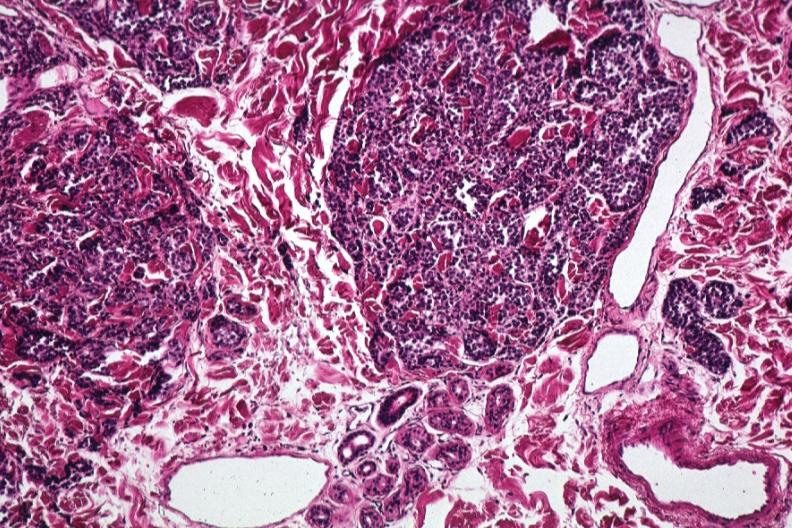what is present?
Answer the question using a single word or phrase. Malignant melanoma 